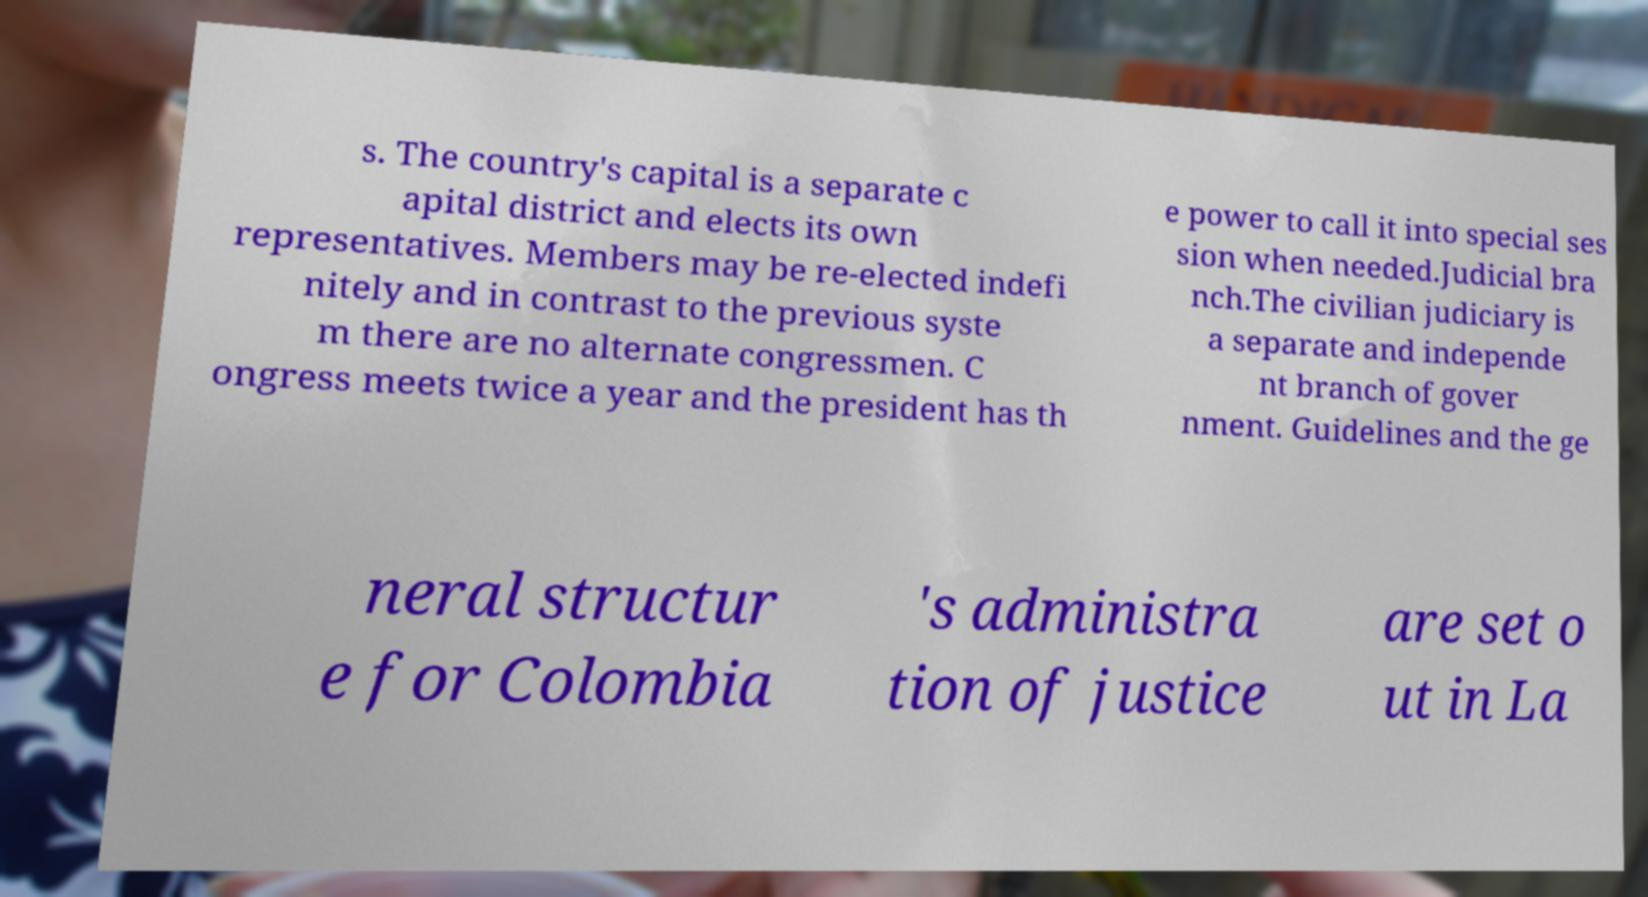Can you read and provide the text displayed in the image?This photo seems to have some interesting text. Can you extract and type it out for me? s. The country's capital is a separate c apital district and elects its own representatives. Members may be re-elected indefi nitely and in contrast to the previous syste m there are no alternate congressmen. C ongress meets twice a year and the president has th e power to call it into special ses sion when needed.Judicial bra nch.The civilian judiciary is a separate and independe nt branch of gover nment. Guidelines and the ge neral structur e for Colombia 's administra tion of justice are set o ut in La 